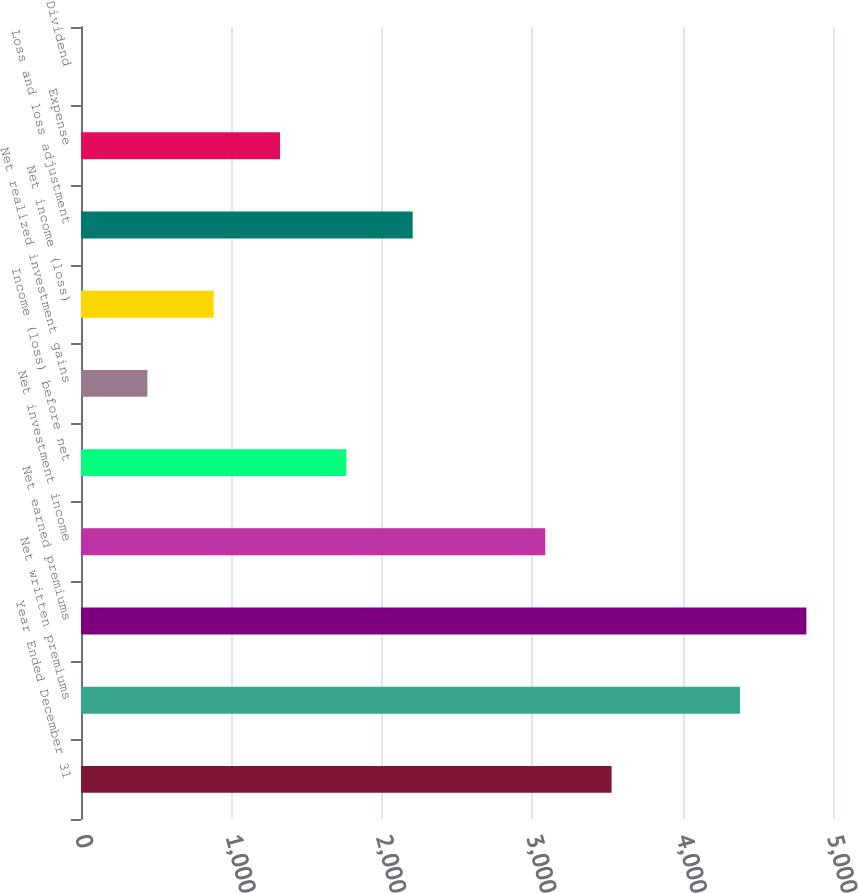Convert chart. <chart><loc_0><loc_0><loc_500><loc_500><bar_chart><fcel>Year Ended December 31<fcel>Net written premiums<fcel>Net earned premiums<fcel>Net investment income<fcel>Income (loss) before net<fcel>Net realized investment gains<fcel>Net income (loss)<fcel>Loss and loss adjustment<fcel>Expense<fcel>Dividend<nl><fcel>3528.08<fcel>4382<fcel>4822.96<fcel>3087.12<fcel>1764.24<fcel>441.36<fcel>882.32<fcel>2205.2<fcel>1323.28<fcel>0.4<nl></chart> 